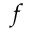<formula> <loc_0><loc_0><loc_500><loc_500>f</formula> 